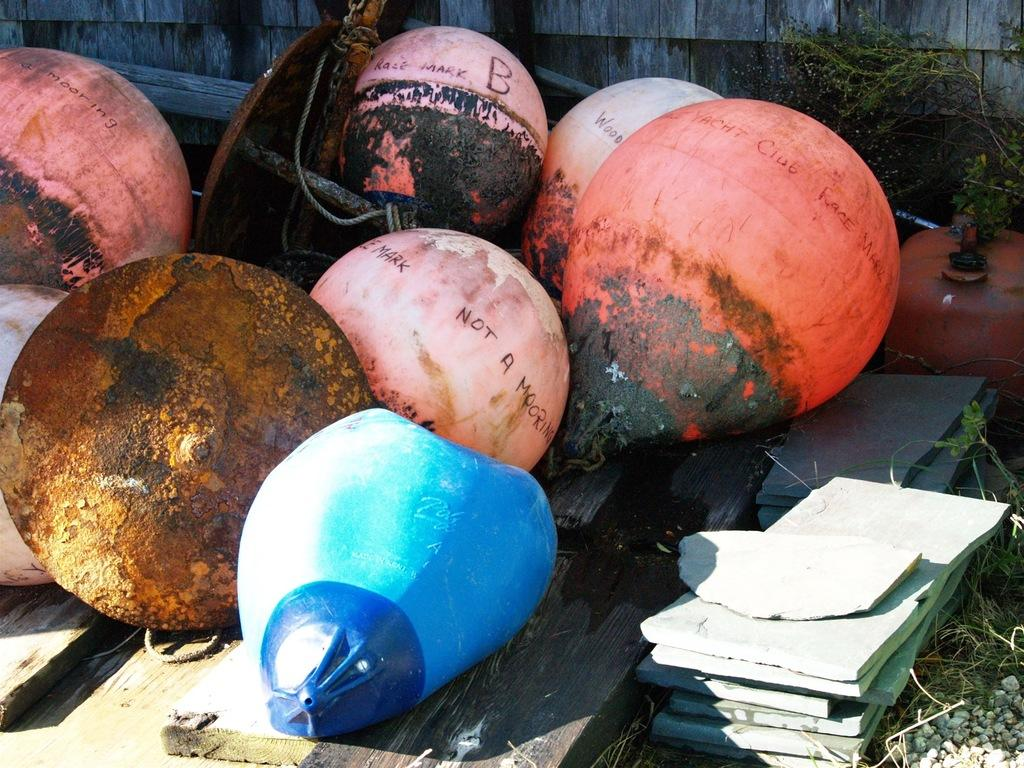What can be seen in the image? There are objects in the image. Can you describe the objects in the background of the image? There are wooden objects and plants in the background of the image. What type of quince is being used to play the piano in the image? There is no piano or quince present in the image. How many fingers can be seen playing the guitar in the image? There is no guitar or fingers playing it in the image. 